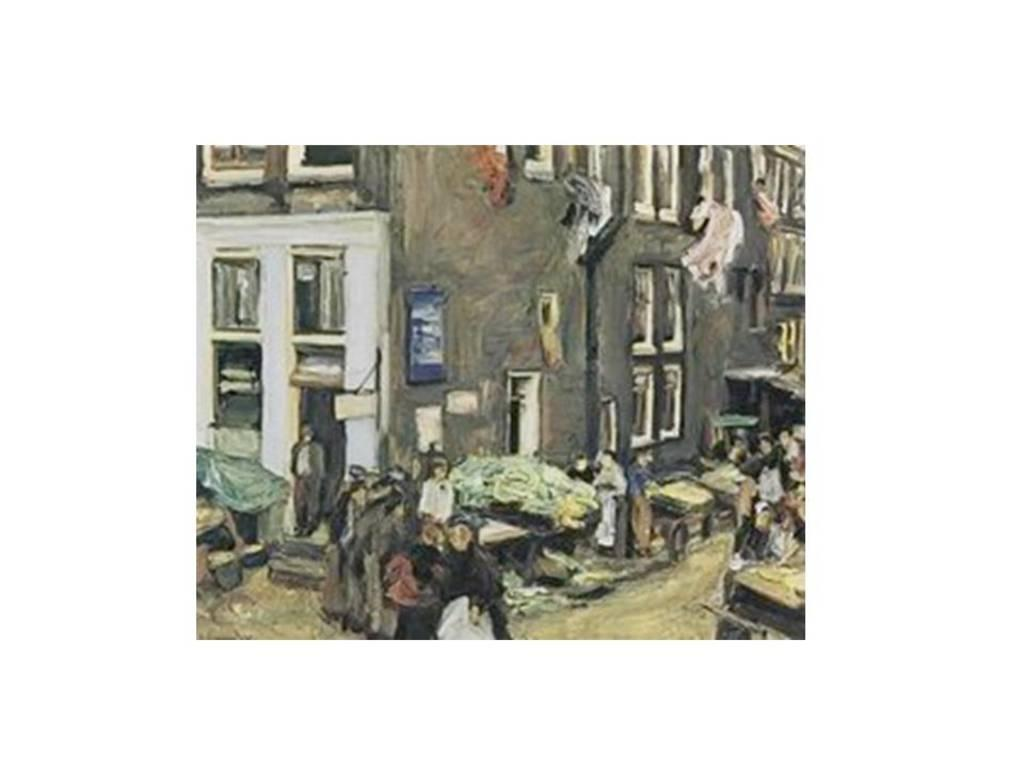What is the main subject of the painting in the image? The painting depicts a building. Are there any other subjects in the painting besides the building? Yes, the painting depicts people as well. What else can be seen in the painting besides the building and people? The painting contains other objects. What type of form does the queen take in the painting? There is no queen present in the painting; it depicts a building, people, and other objects. 